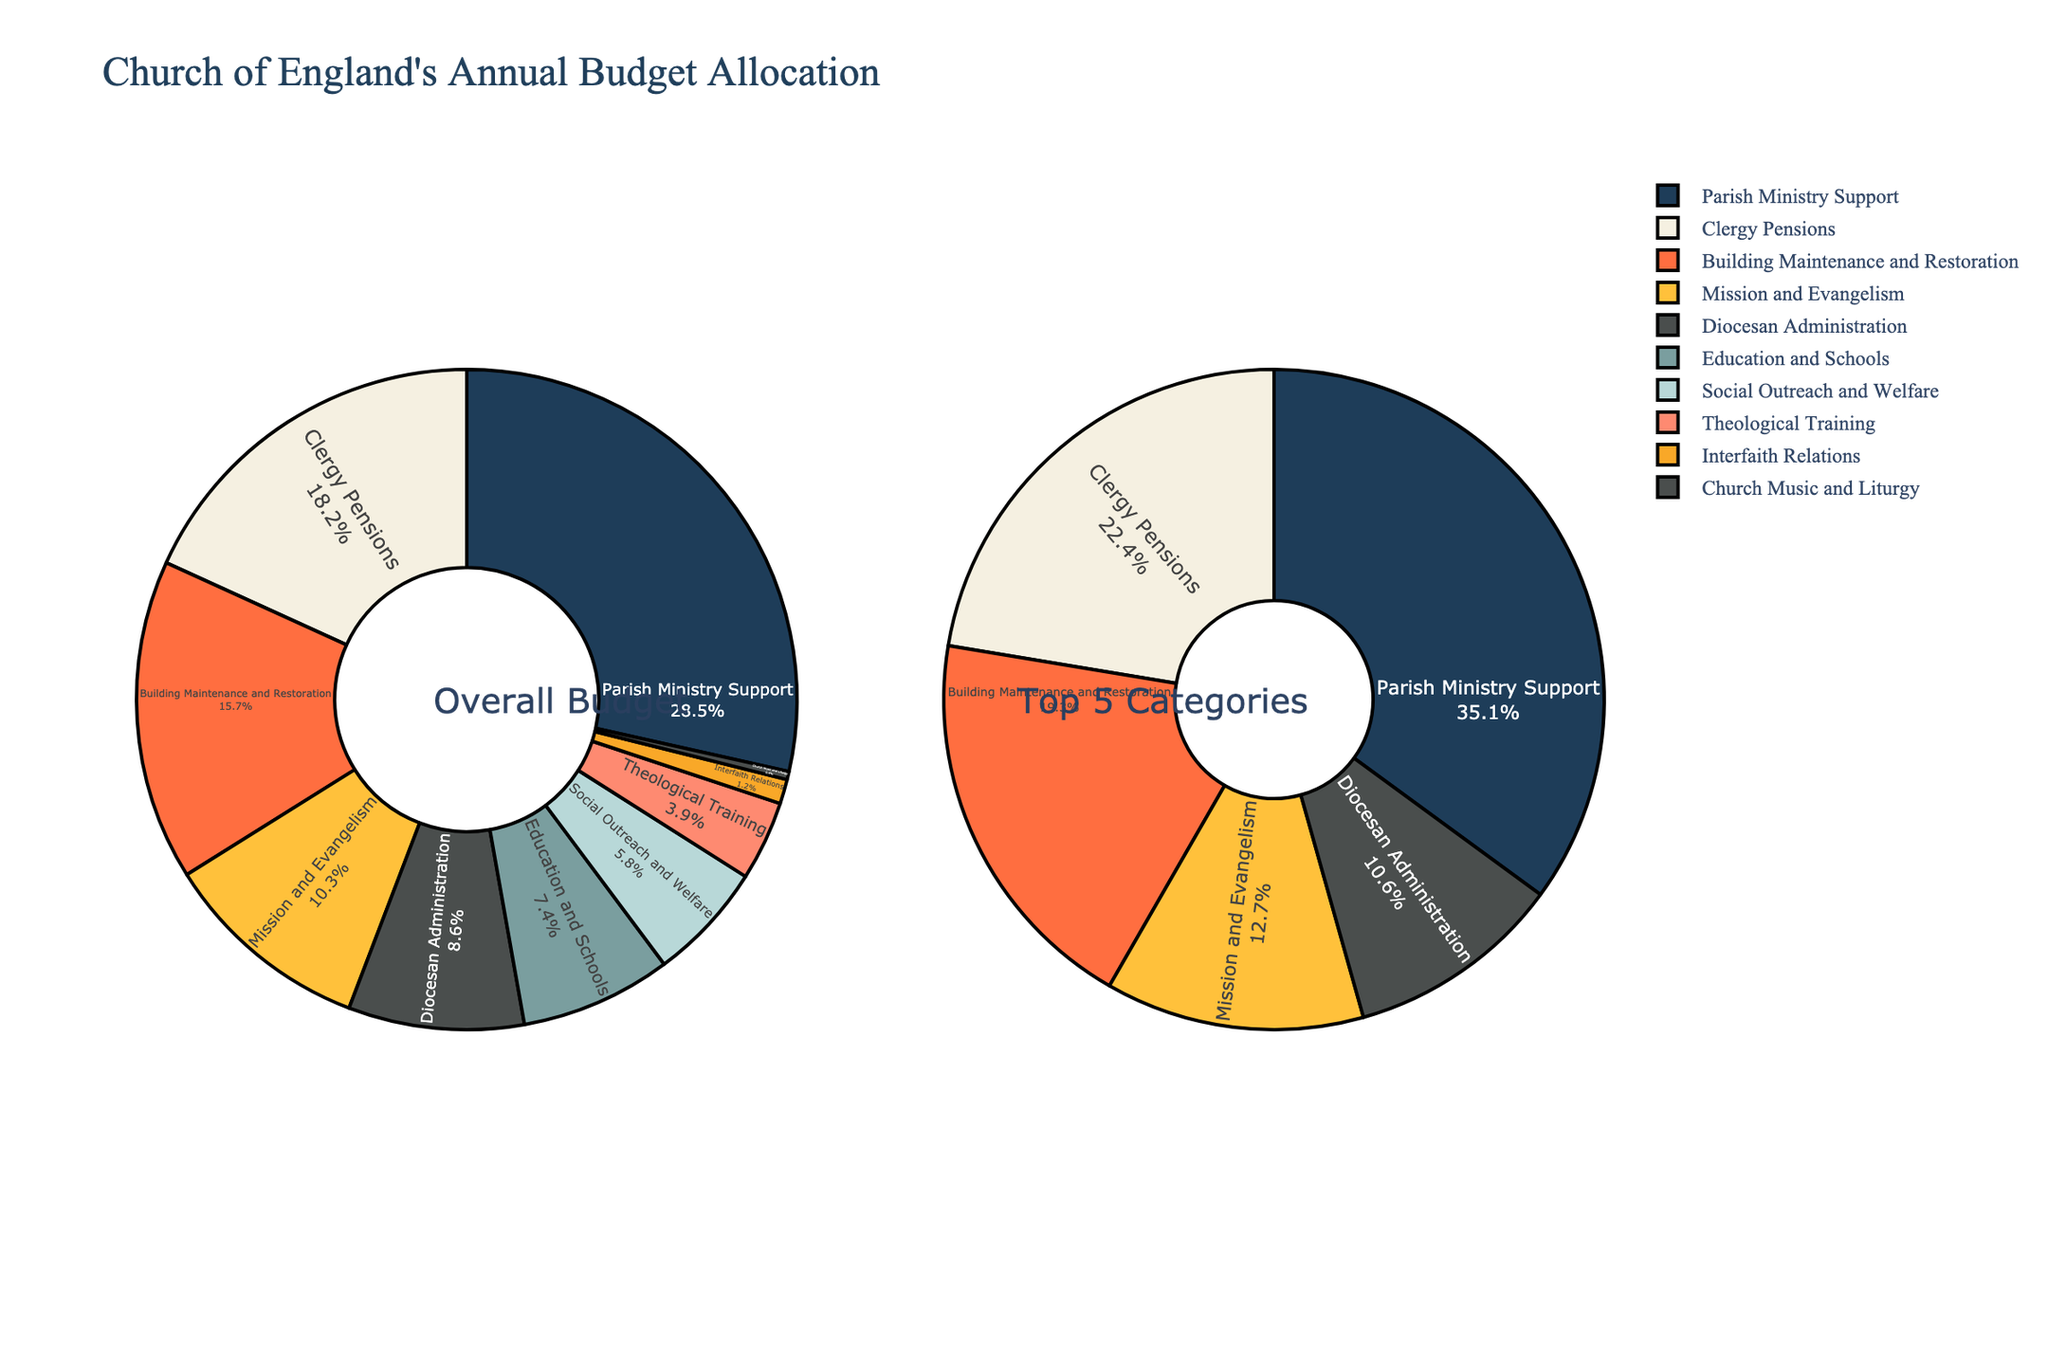Which category receives the highest percentage of the Church of England's annual budget? By examining the pie chart, we can see that the "Parish Ministry Support" category takes up the largest slice of the pie.
Answer: Parish Ministry Support Which category receives a smaller percentage of the budget: Building Maintenance and Restoration or Diocesan Administration? By comparing the sizes of the respective pie slices, we can see that "Building Maintenance and Restoration" receives 15.7%, while "Diocesan Administration" receives 8.6%.
Answer: Diocesan Administration Which two categories have the smallest allocations, and what are their combined percentages? By looking at the pie chart and identifying the smallest slices, we find that "Church Music and Liturgy" (0.4%) and "Interfaith Relations" (1.2%) are the smallest. The combined percentage is 0.4% + 1.2% = 1.6%.
Answer: Church Music and Liturgy, Interfaith Relations; 1.6% What's the combined percentage of the top 3 budget allocations? The top 3 categories based on their allocation percentages are "Parish Ministry Support" (28.5%), "Clergy Pensions" (18.2%), and "Building Maintenance and Restoration" (15.7%). Adding these together: 28.5% + 18.2% + 15.7% = 62.4%.
Answer: 62.4% How does the allocation for "Mission and Evangelism" compare to that for "Education and Schools"? From the pie chart, "Mission and Evangelism" receives 10.3% of the budget, while "Education and Schools" receives 7.4%. This shows "Mission and Evangelism" has a higher allocation.
Answer: Mission and Evangelism receives more What is the average percentage allocation for the top 5 categories? The top 5 categories are "Parish Ministry Support" (28.5%), "Clergy Pensions" (18.2%), "Building Maintenance and Restoration" (15.7%), "Mission and Evangelism" (10.3%), and "Diocesan Administration" (8.6%). Summing these percentages: 28.5% + 18.2% + 15.7% + 10.3% + 8.6% = 81.3%. The average is 81.3% / 5 = 16.26%.
Answer: 16.26% Which category has nearly double the budget allocation of "Social Outreach and Welfare"? The percentage allocation of "Social Outreach and Welfare" is 5.8%. Doubling this is approximately 11.6%. "Mission and Evangelism," at 10.3%, is closest but not quite double. Hence, there isn't a category that is exactly double; however, "Mission and Evangelism" (10.3%) is the closest.
Answer: Mission and Evangelism What is the percentage difference between "Parish Ministry Support" and "Theological Training"? "Parish Ministry Support" receives 28.5%, and "Theological Training" receives 3.9%. The difference is 28.5% - 3.9% = 24.6%.
Answer: 24.6% Which categories combined account for about one-third of the budget? One-third of the budget is approximately 33.33%. By examining the pie chart, we see "Parish Ministry Support" (28.5%) + "Theological Training" (3.9%) totals 32.4%, which is closest to one-third.
Answer: Parish Ministry Support and Theological Training 